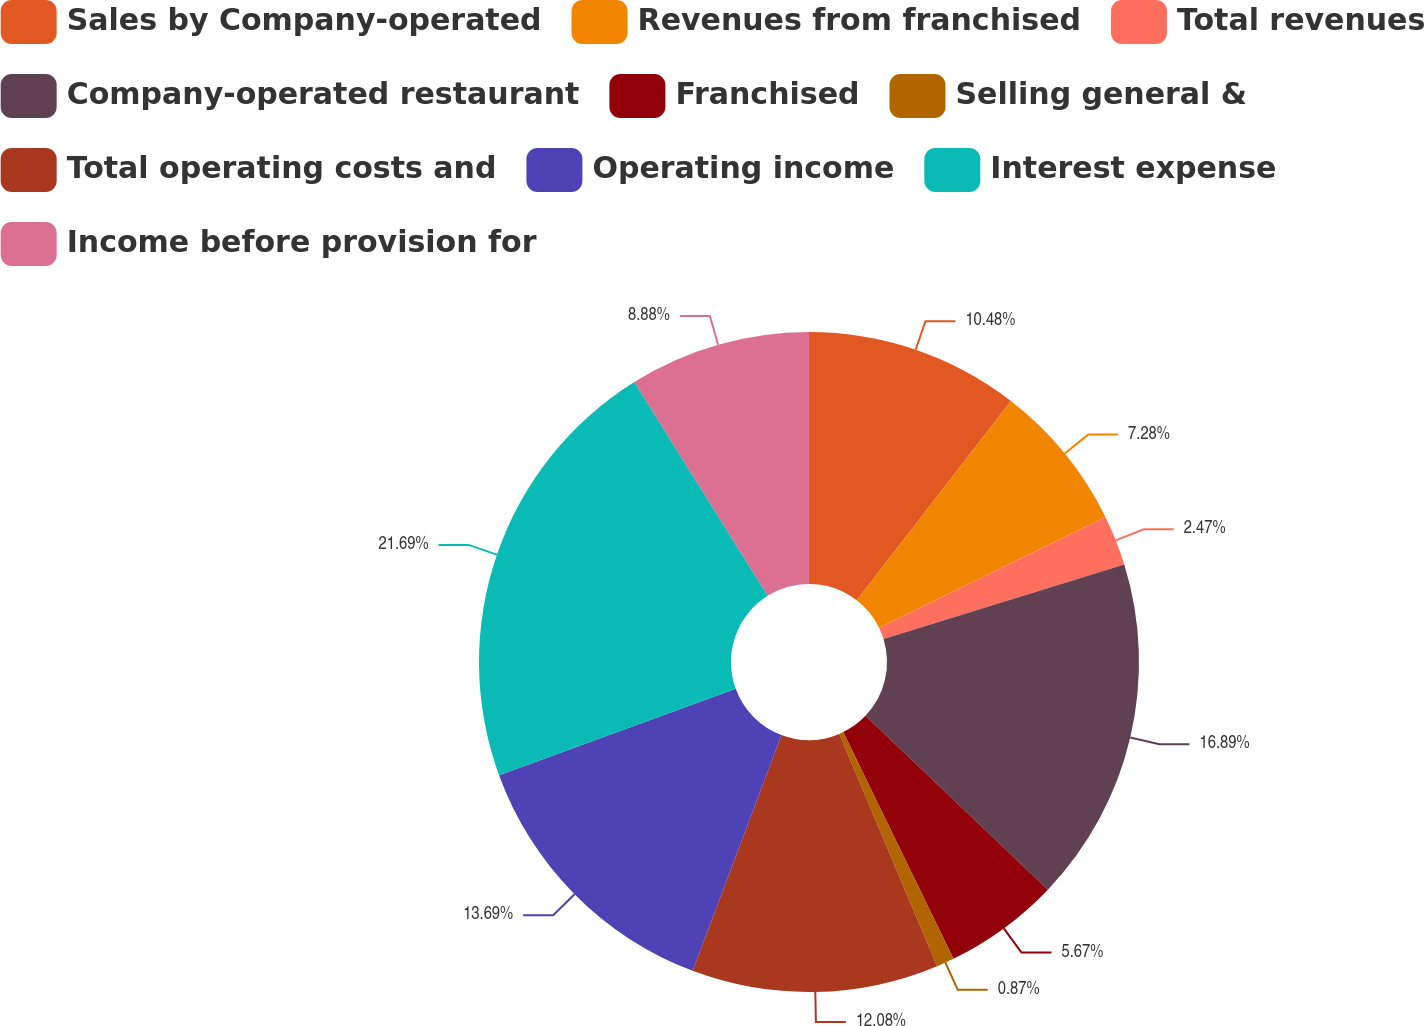Convert chart to OTSL. <chart><loc_0><loc_0><loc_500><loc_500><pie_chart><fcel>Sales by Company-operated<fcel>Revenues from franchised<fcel>Total revenues<fcel>Company-operated restaurant<fcel>Franchised<fcel>Selling general &<fcel>Total operating costs and<fcel>Operating income<fcel>Interest expense<fcel>Income before provision for<nl><fcel>10.48%<fcel>7.28%<fcel>2.47%<fcel>16.89%<fcel>5.67%<fcel>0.87%<fcel>12.08%<fcel>13.69%<fcel>21.7%<fcel>8.88%<nl></chart> 